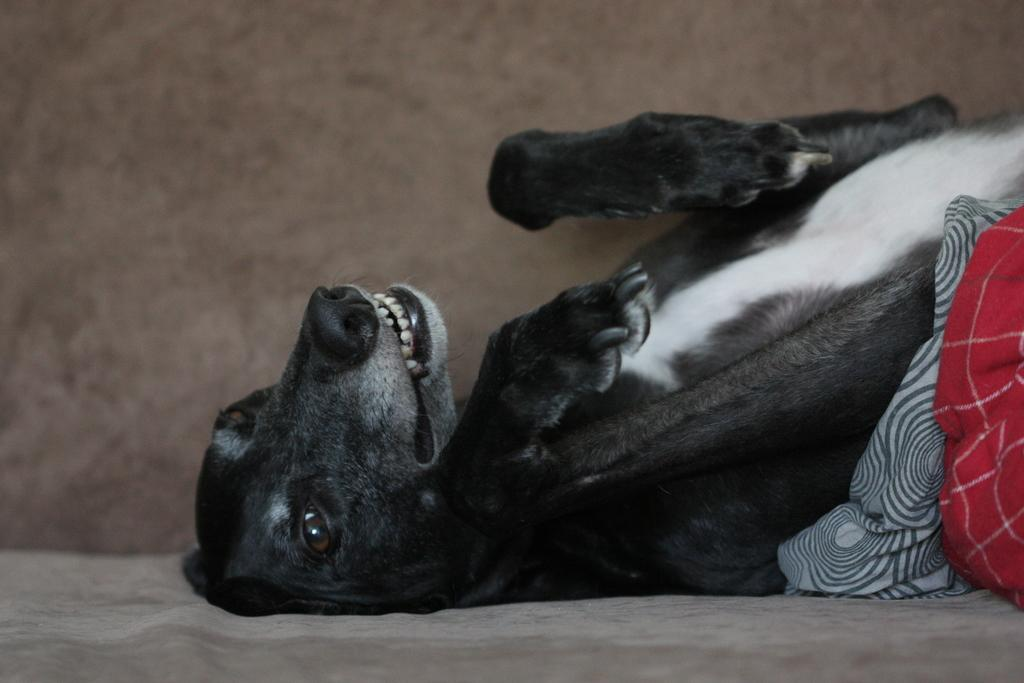What type of animal is in the image? There is a dog in the image. What else can be seen on the right side of the image? There are clothes on the right side of the image. Can you see any mountains in the image? There are no mountains visible in the image. How does the dog push the clothes in the image? The dog does not push the clothes in the image; there is no interaction between the dog and the clothes. 